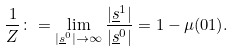<formula> <loc_0><loc_0><loc_500><loc_500>\frac { 1 } { Z } \colon = \lim _ { | \underline { s } ^ { 0 } | \to \infty } \frac { | \underline { s } ^ { 1 } | } { | \underline { s } ^ { 0 } | } = 1 - \mu ( 0 1 ) .</formula> 